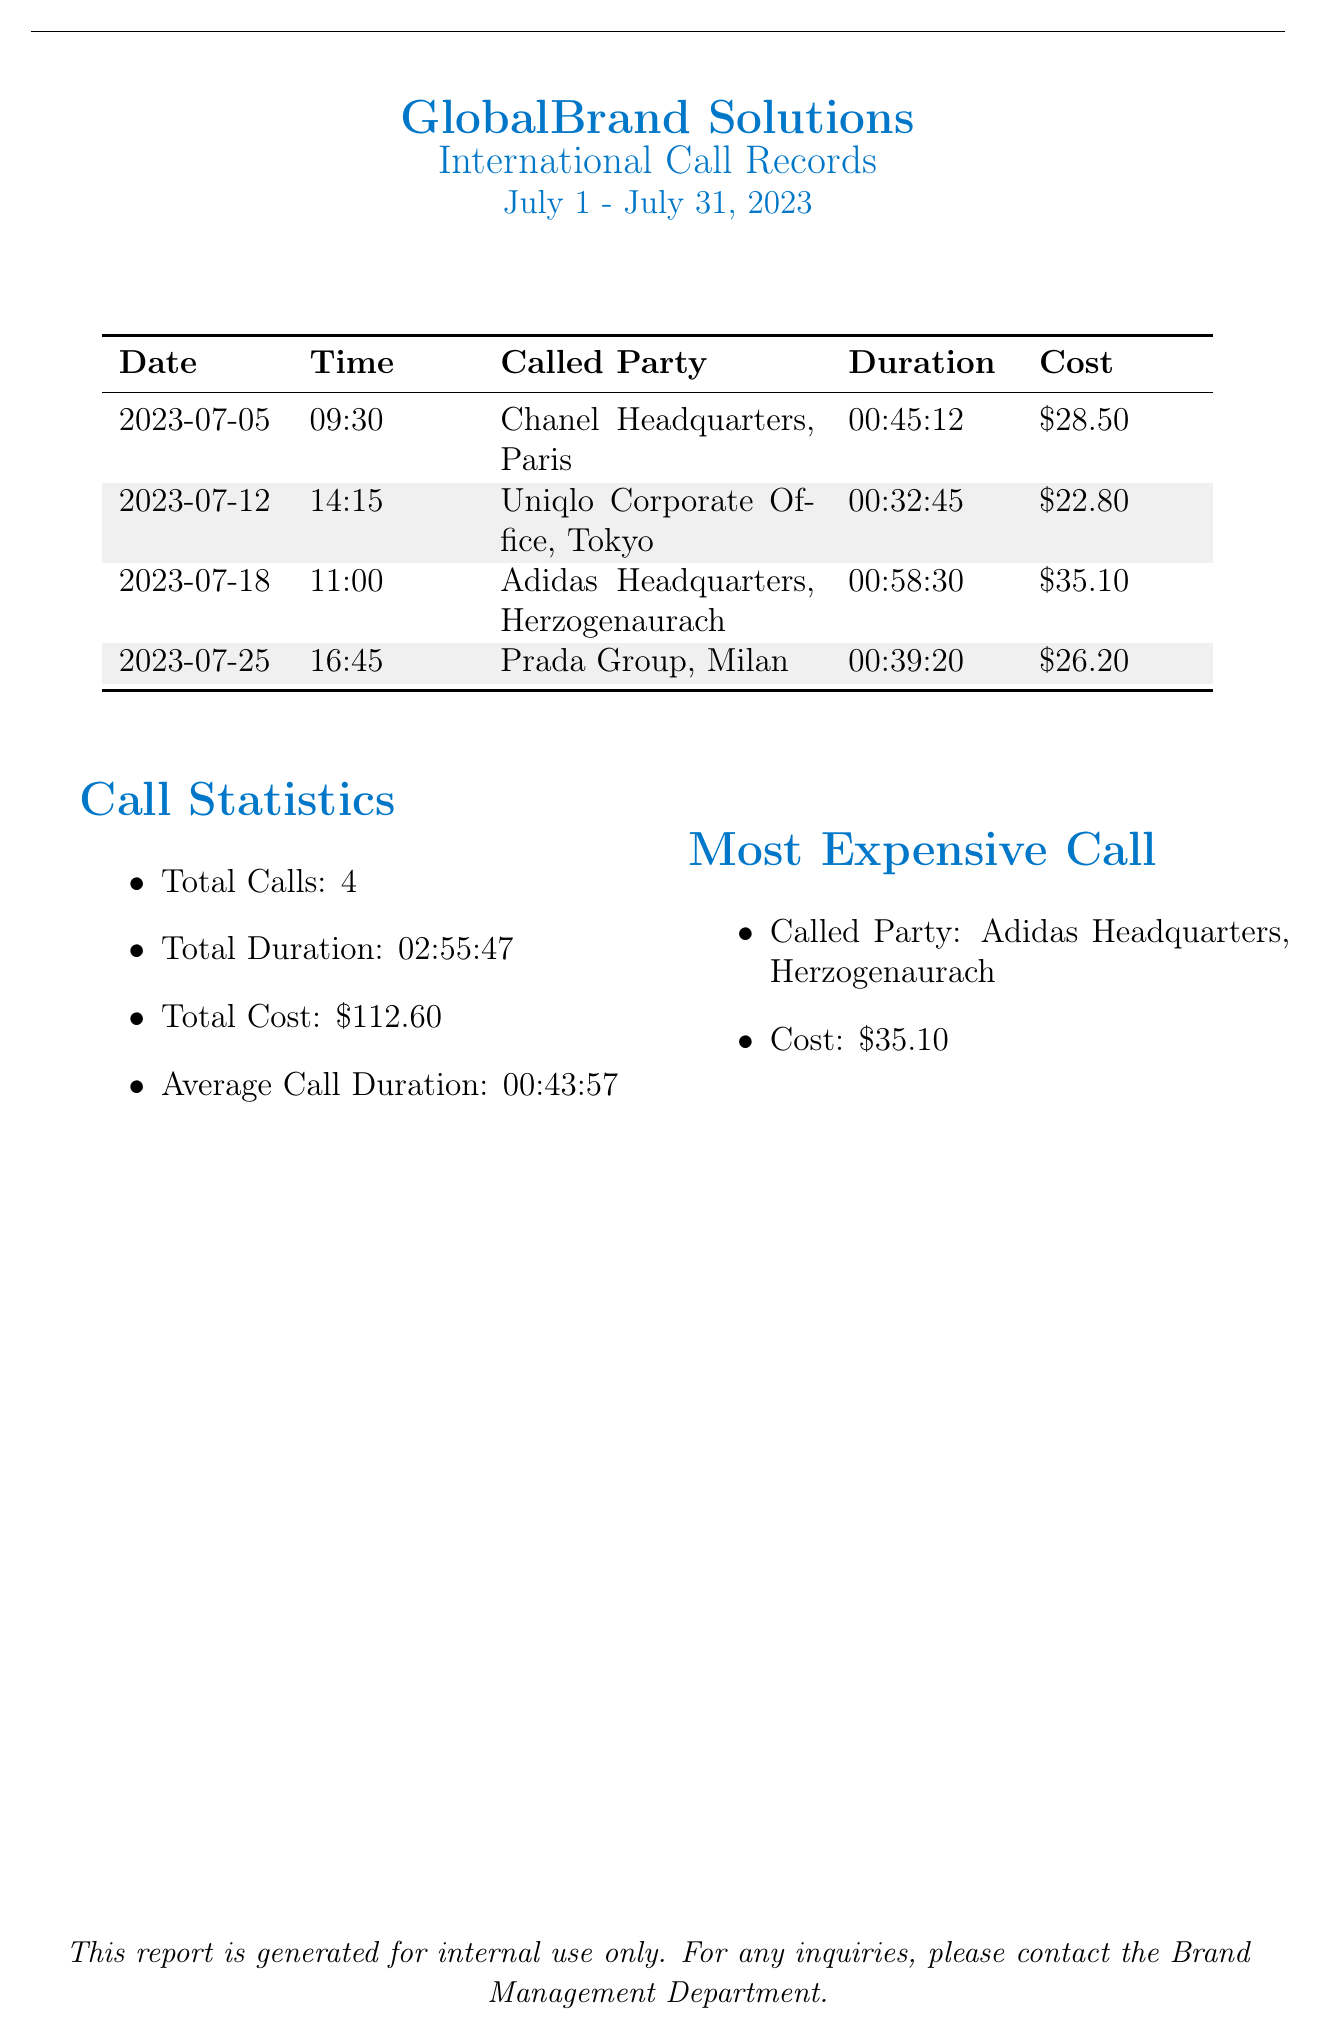What is the total number of calls? The total number of calls is directly mentioned in the statistics section of the document.
Answer: 4 What was the most expensive call? The document specifies the most expensive call along with the called party's name and its cost.
Answer: Adidas Headquarters, Herzogenaurach What is the total duration of all calls? The total duration is calculated and specified in the statistics section.
Answer: 02:55:47 What was the cost of the call to Chanel Headquarters? The cost for the call to Chanel Headquarters is listed in the call records table.
Answer: $28.50 Which company was called on July 12, 2023? The date of the call is provided, along with the called party in the call records section.
Answer: Uniqlo Corporate Office, Tokyo What is the average call duration? The average call duration is calculated and provided in the call statistics.
Answer: 00:43:57 What is the cost of the call to Prada Group? The cost for the call to Prada Group is recorded in the call records table.
Answer: $26.20 How many calls were made to companies based in Europe? The document lists three calls made to companies in Europe, verified by the locations in the call records.
Answer: 3 